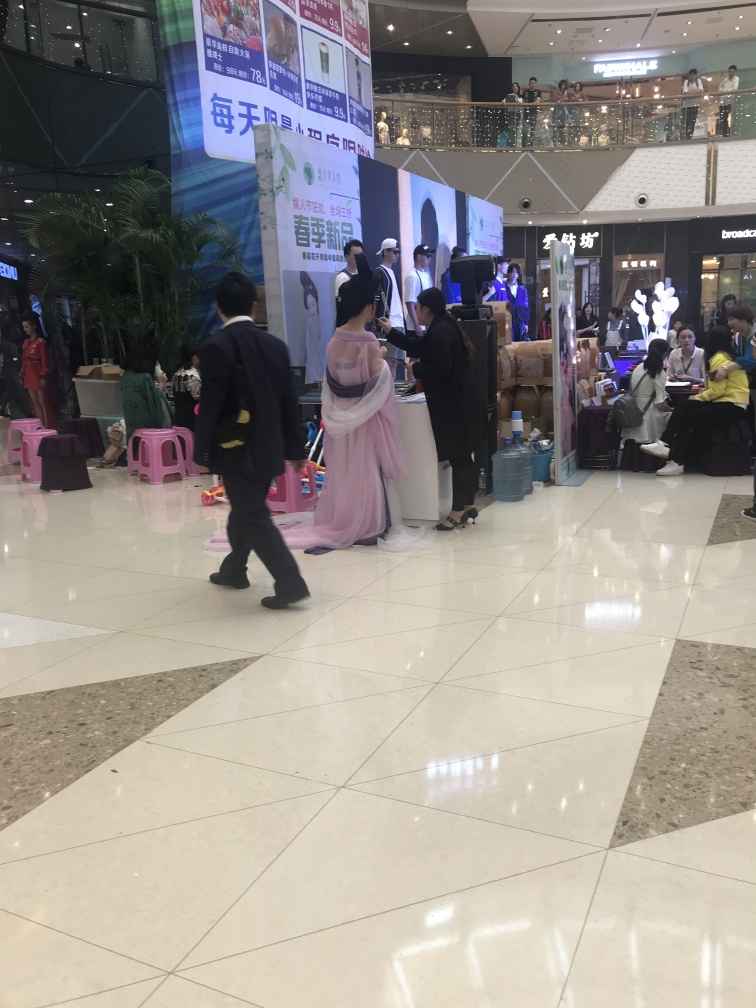What kind of products or services are being promoted in the image? Based on the banners and stands, the promotion seems to encompass a variety of products or services, with electronic gadgets being a prominent theme. There's also a traditional element suggested by the attire of some participants, which may indicate cultural or artistic products. Are there any notable details about the participants' attire? Yes, there are individuals dressed in modern and what appear to be traditional garments, which provides a visual contrast and may hint at a fusion of contemporary and cultural themes at the event. 